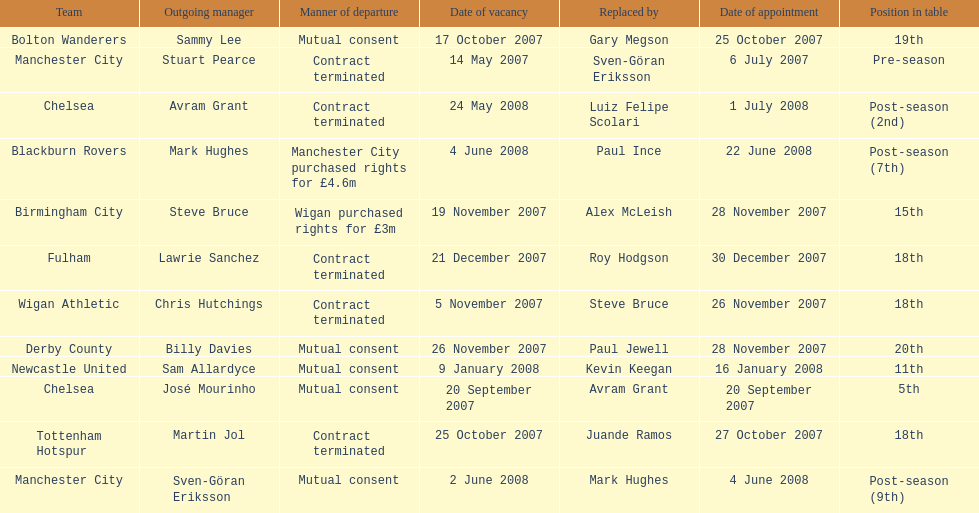Who was manager of manchester city after stuart pearce left in 2007? Sven-Göran Eriksson. 